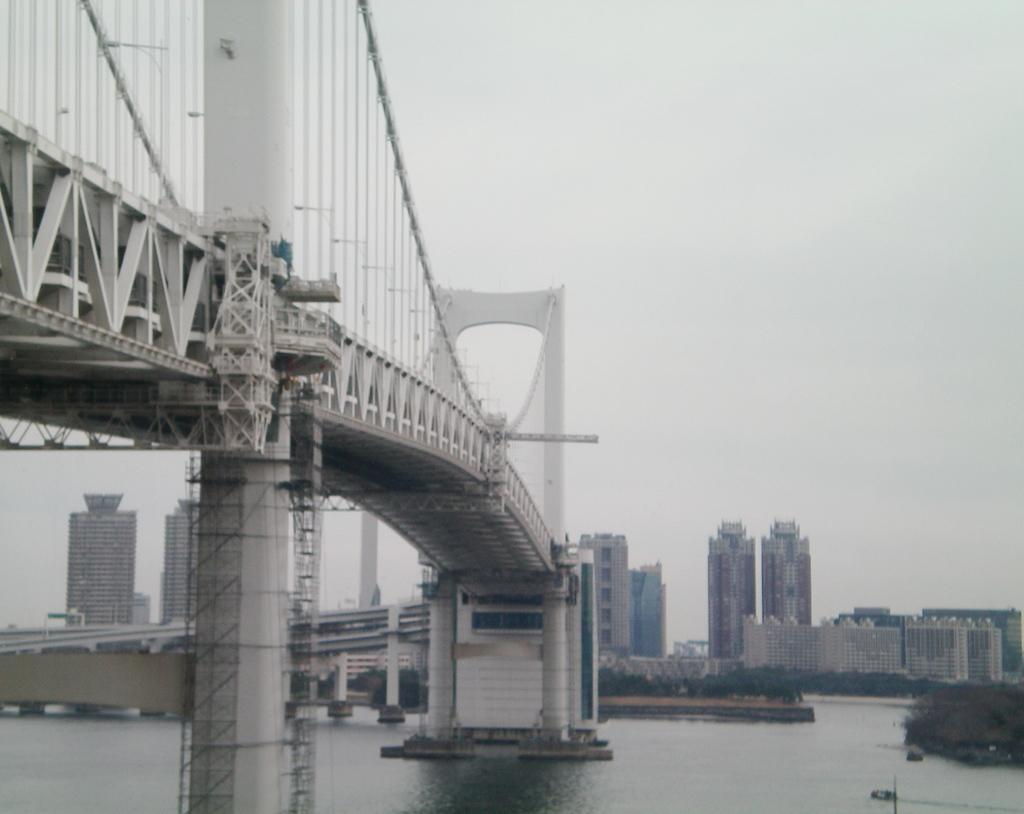What structure is located on the left side of the image? There is a bridge on the left side of the image. What natural feature is at the bottom of the image? There is a river at the bottom of the image. What type of man-made structures can be seen on the right side of the image? There are buildings on the right side of the image. What is visible at the top of the image? The sky is cloudy and visible at the top of the image. What type of lace can be seen hanging from the bridge in the image? There is no lace present on the bridge in the image. Is there a note attached to the river in the image? There is no note present in the image. 